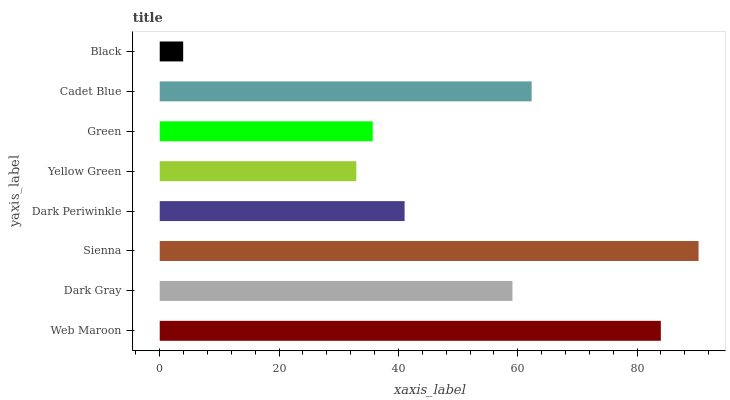Is Black the minimum?
Answer yes or no. Yes. Is Sienna the maximum?
Answer yes or no. Yes. Is Dark Gray the minimum?
Answer yes or no. No. Is Dark Gray the maximum?
Answer yes or no. No. Is Web Maroon greater than Dark Gray?
Answer yes or no. Yes. Is Dark Gray less than Web Maroon?
Answer yes or no. Yes. Is Dark Gray greater than Web Maroon?
Answer yes or no. No. Is Web Maroon less than Dark Gray?
Answer yes or no. No. Is Dark Gray the high median?
Answer yes or no. Yes. Is Dark Periwinkle the low median?
Answer yes or no. Yes. Is Black the high median?
Answer yes or no. No. Is Black the low median?
Answer yes or no. No. 